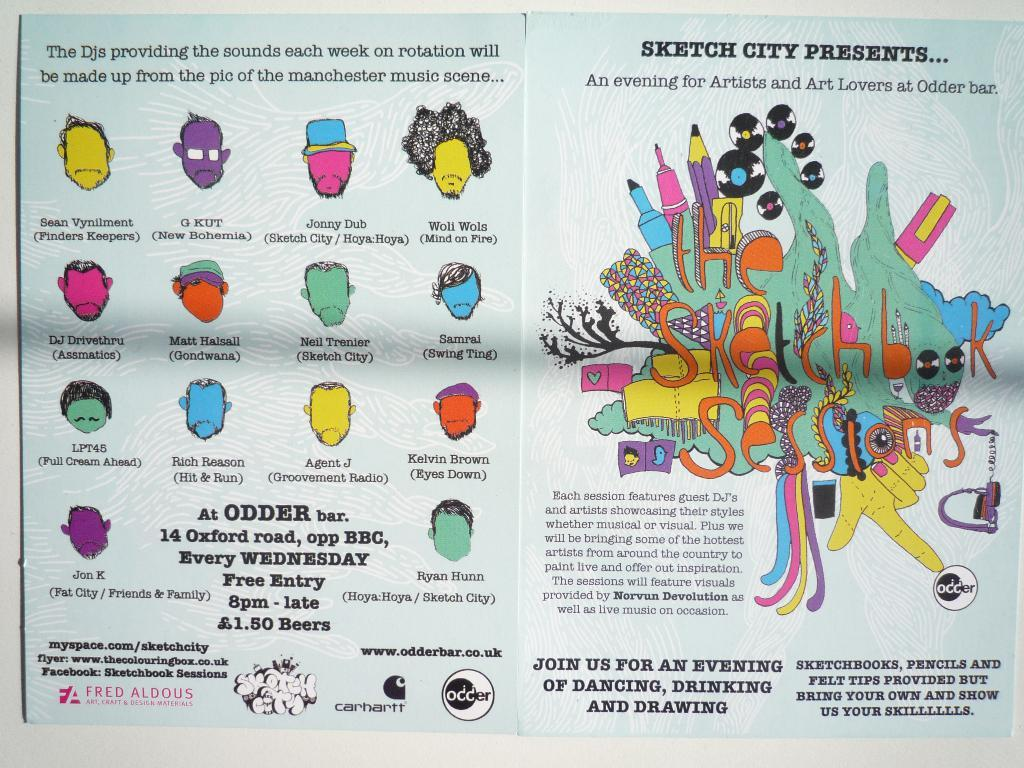<image>
Give a short and clear explanation of the subsequent image. the word sketch that is on a magazine page 